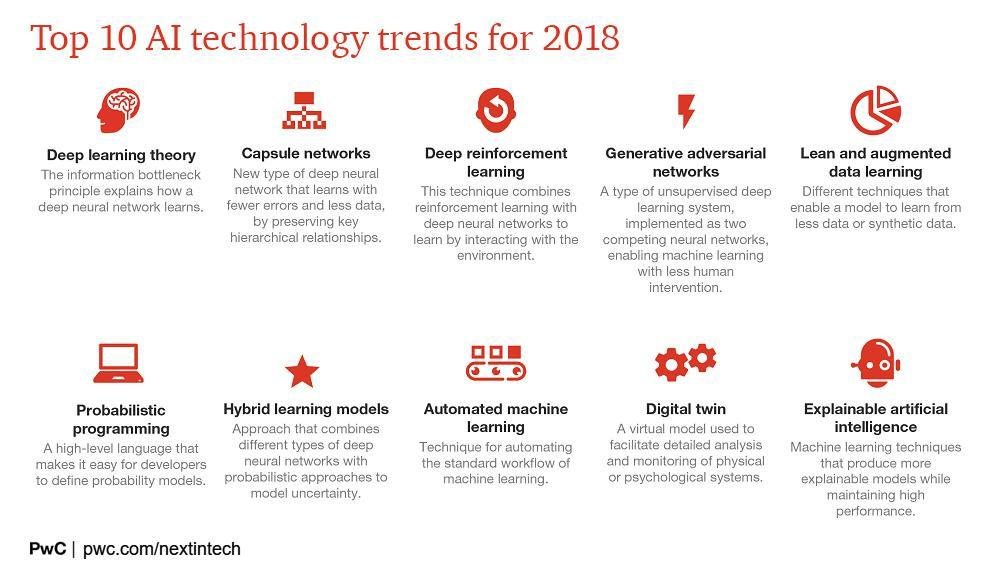What techniques enable a model to learn from less data or synthetic data
Answer the question with a short phrase. Lean and augmented data learning What is the technique for automating the workflow of machine learning? Automated machine learning What is a virtual model used to facilitate analysis and monitoring of psychological systems? Digital twin What do you call networks that learn with less errors, less data, by preserving hierarchical relationships? capsule networks What is a high-level language that helps developers to define probability models? probabilistic programming 